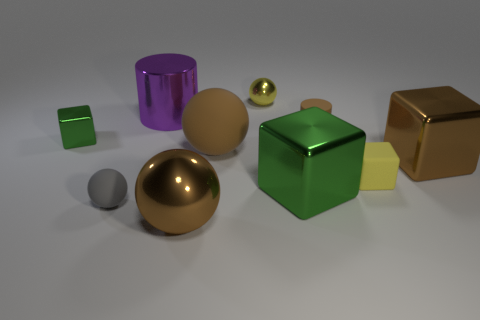Subtract all metallic blocks. How many blocks are left? 1 Subtract all cylinders. How many objects are left? 8 Subtract 0 green cylinders. How many objects are left? 10 Subtract all tiny blocks. Subtract all brown shiny cubes. How many objects are left? 7 Add 7 green cubes. How many green cubes are left? 9 Add 1 large cylinders. How many large cylinders exist? 2 